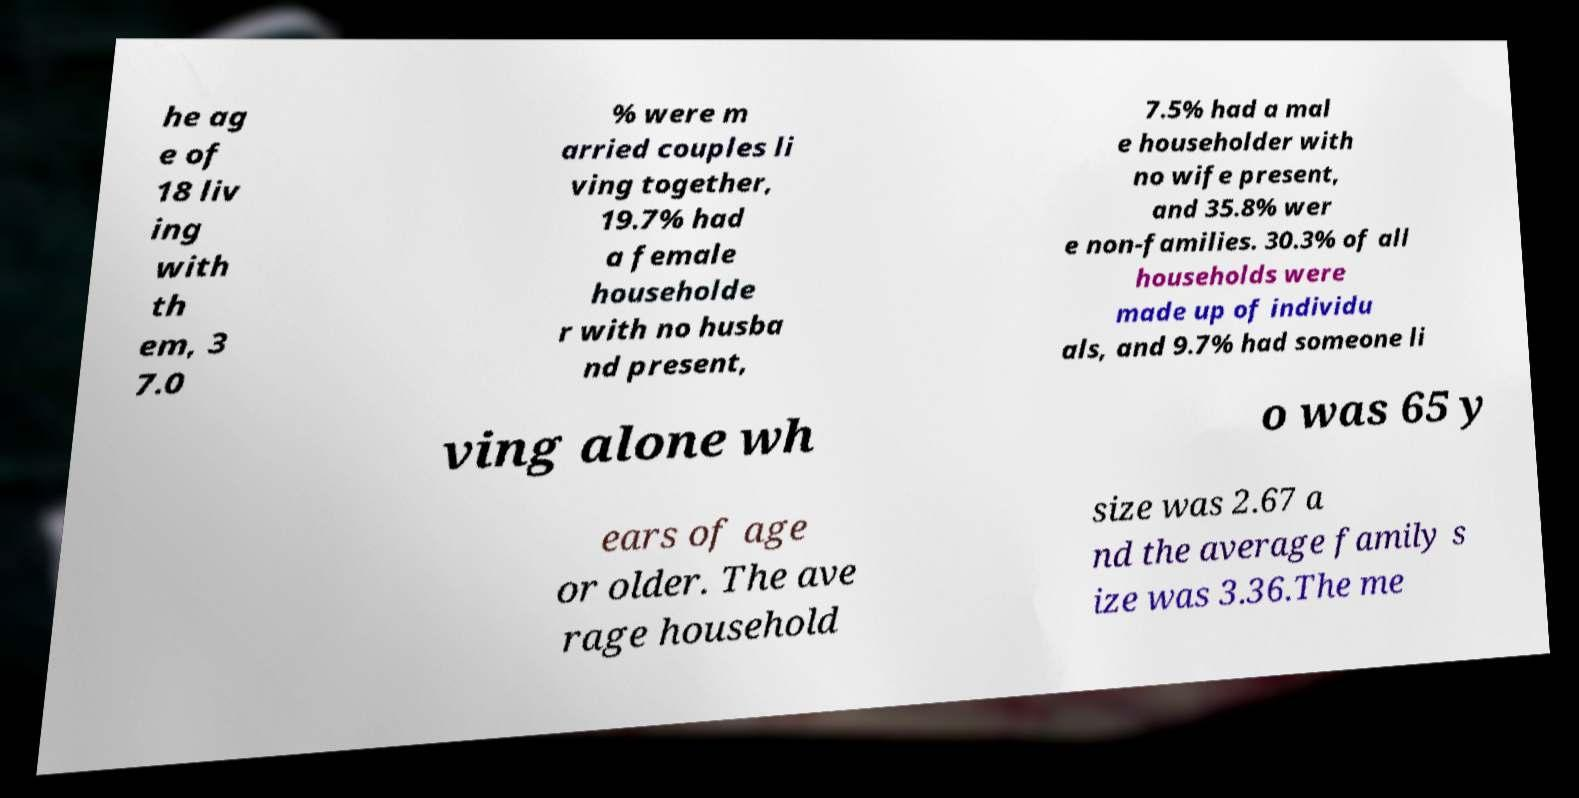What messages or text are displayed in this image? I need them in a readable, typed format. he ag e of 18 liv ing with th em, 3 7.0 % were m arried couples li ving together, 19.7% had a female householde r with no husba nd present, 7.5% had a mal e householder with no wife present, and 35.8% wer e non-families. 30.3% of all households were made up of individu als, and 9.7% had someone li ving alone wh o was 65 y ears of age or older. The ave rage household size was 2.67 a nd the average family s ize was 3.36.The me 